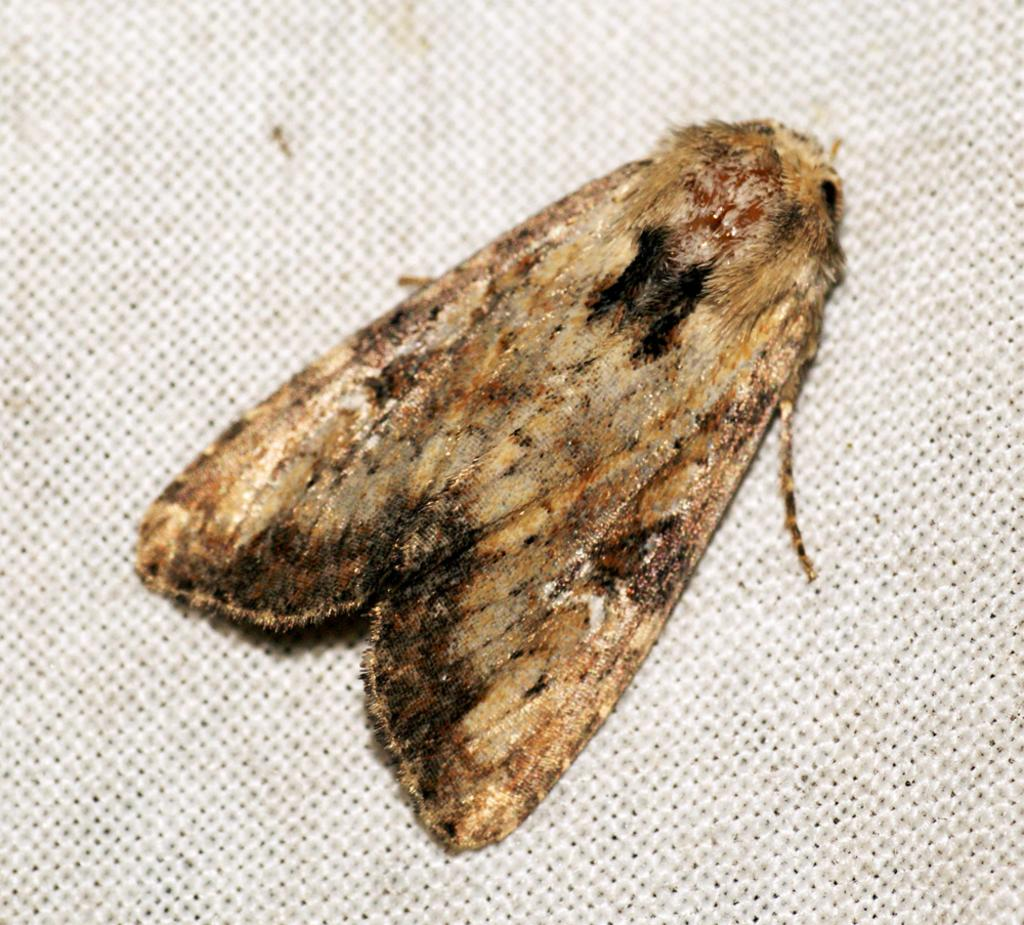What type of insect is depicted in the image? There is a moth represented in the image. What is the opinion of the moth about the quality of the produce in the image? There is no produce present in the image, and insects do not have opinions. 